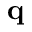<formula> <loc_0><loc_0><loc_500><loc_500>q</formula> 